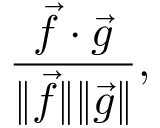<formula> <loc_0><loc_0><loc_500><loc_500>\frac { \vec { f } \cdot \vec { g } } { \| \vec { f } \| \| \vec { g } \| } ,</formula> 